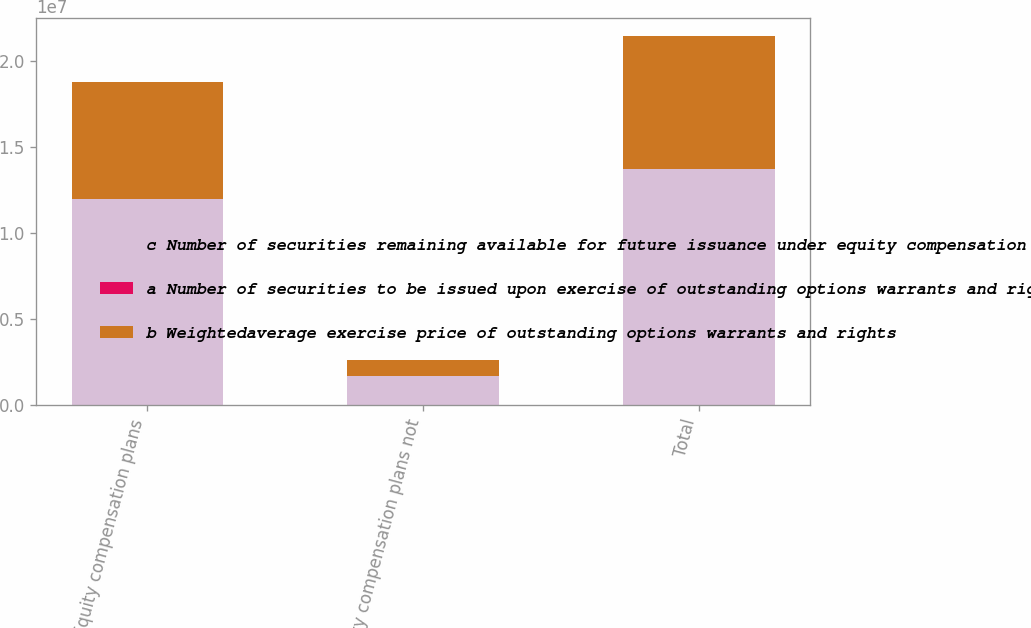Convert chart to OTSL. <chart><loc_0><loc_0><loc_500><loc_500><stacked_bar_chart><ecel><fcel>Equity compensation plans<fcel>Equity compensation plans not<fcel>Total<nl><fcel>c Number of securities remaining available for future issuance under equity compensation plans excluding securities reflected in column a<fcel>1.20101e+07<fcel>1.71505e+06<fcel>1.37251e+07<nl><fcel>a Number of securities to be issued upon exercise of outstanding options warrants and rights<fcel>37.46<fcel>40.44<fcel>37.83<nl><fcel>b Weightedaverage exercise price of outstanding options warrants and rights<fcel>6.79388e+06<fcel>927113<fcel>7.72099e+06<nl></chart> 